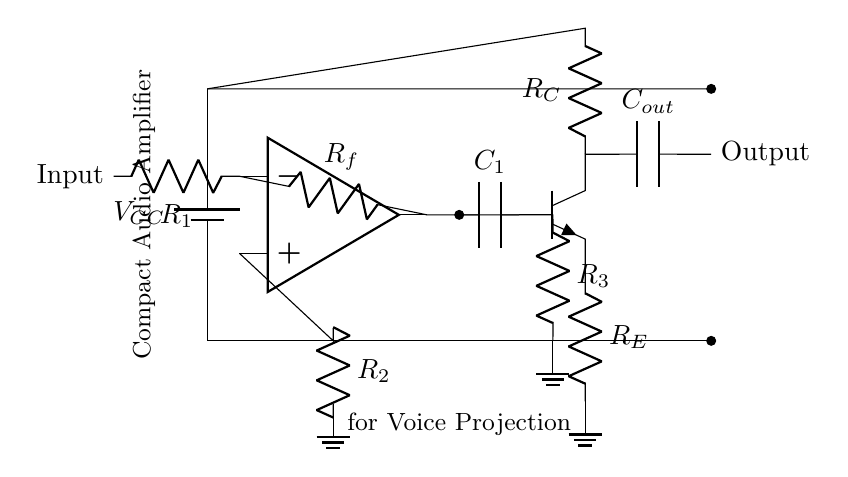What type of circuit is this? This circuit is a compact audio amplifier designed for enhancing voice projection. The key components and their configuration indicate its purpose in amplifying audio signals.
Answer: Audio amplifier What is the power supply voltage? The circuit uses a battery denoted as VCC, typically indicating a nominal voltage supply standard for low power devices. The schematic does not specify an exact value, but it is commonly around 5V for similar circuits.
Answer: VCC Which component is used for feedback in the circuit? The feedback resistor is illustrated as Rf and is connected between the output of the operational amplifier and its inverting input, allowing it to control the gain of the amplifier.
Answer: Rf What is the purpose of the capacitor labeled C1? The capacitor C1 is used for coupling, allowing AC signals to pass while blocking DC components, which is important in audio applications to prevent distortion of the signal.
Answer: Coupling How many resistors are present in the circuit? There are four resistors shown in the circuit: R1, R2, Rf, and R3. Including R_E and R_C connected to the transistor, there are six resistors total.
Answer: Six What is the role of the transistor in the circuit? The npn transistor is used for amplification as part of the output stage, helping to drive the output signal stronger and ensuring sufficient power for the speaker or amplifier load.
Answer: Amplification 